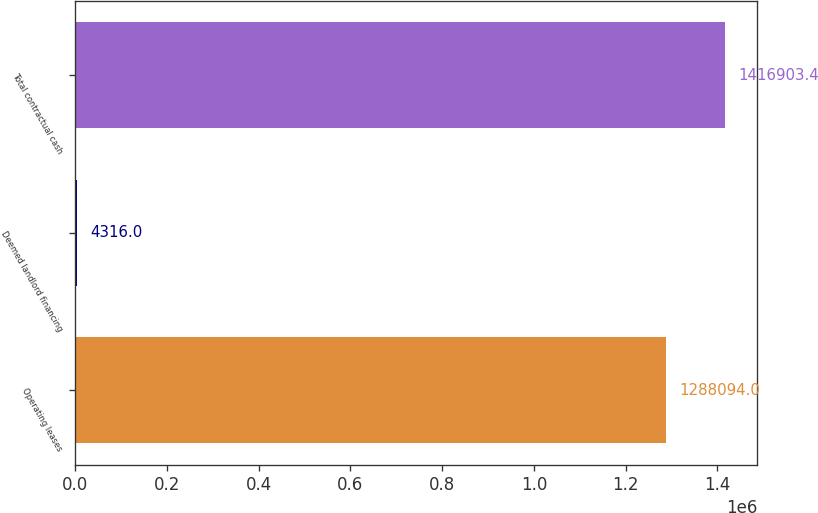Convert chart to OTSL. <chart><loc_0><loc_0><loc_500><loc_500><bar_chart><fcel>Operating leases<fcel>Deemed landlord financing<fcel>Total contractual cash<nl><fcel>1.28809e+06<fcel>4316<fcel>1.4169e+06<nl></chart> 